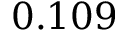Convert formula to latex. <formula><loc_0><loc_0><loc_500><loc_500>0 . 1 0 9</formula> 